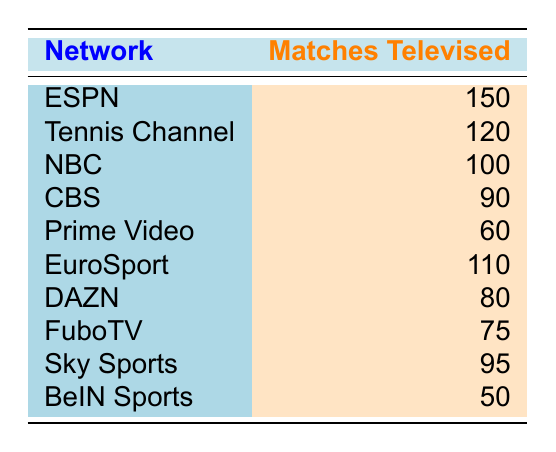What network televised the most tennis matches in 2023? The data shows the number of matches televised by each network. According to the table, ESPN has the highest count with 150 matches.
Answer: ESPN How many matches were televised by the Tennis Channel in 2023? The table explicitly lists that the Tennis Channel televised 120 matches.
Answer: 120 What is the total number of matches televised by NBC and CBS? To find the total, we need to sum the matches from NBC (100) and CBS (90): 100 + 90 = 190.
Answer: 190 Did BeIN Sports broadcast more than 50 tennis matches? The data indicates BeIN Sports televised exactly 50 matches, so it did not broadcast more than 50 matches.
Answer: No What is the difference in the number of matches televised between ESPN and EuroSport? ESPN had 150 matches, while EuroSport had 110 matches. The difference is 150 - 110 = 40.
Answer: 40 Which network had the fewest televised matches, and how many did it broadcast? Referring to the table, BeIN Sports has the fewest matches with 50.
Answer: BeIN Sports, 50 If Prime Video and FuboTV's matches are combined, how many would that total? Prime Video televised 60 matches and FuboTV televised 75 matches. Adding these gives 60 + 75 = 135.
Answer: 135 How many more matches did DAZN broadcast than Sky Sports? DAZN televised 80 matches, while Sky Sports televised 95 matches. Subtracting gives 80 - 95 = -15, indicating DAZN broadcasted 15 fewer matches.
Answer: 15 fewer matches What percentage of matches televised were by networks other than ESPN? To find this, we take the total of all other networks (120 + 100 + 90 + 60 + 110 + 80 + 75 + 95 + 50 = 820) and find the percentage of 820 from the total (150 + 820 = 970). Percentage = (820/970) * 100 ≈ 84.54%.
Answer: Approximately 84.54% 